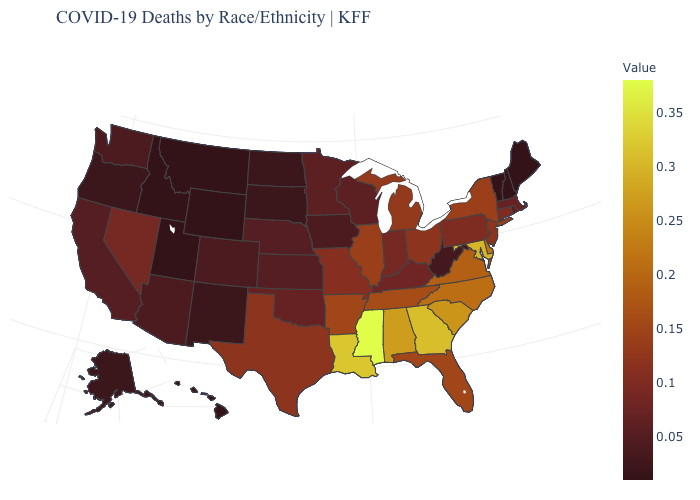Among the states that border Mississippi , which have the highest value?
Keep it brief. Louisiana. Which states have the lowest value in the USA?
Concise answer only. Hawaii, Idaho, Maine, Montana, New Hampshire, Utah, Vermont, Wyoming. Does Maryland have the highest value in the South?
Give a very brief answer. No. Does Ohio have a lower value than South Dakota?
Quick response, please. No. Which states have the highest value in the USA?
Give a very brief answer. Mississippi. Does New York have the lowest value in the Northeast?
Concise answer only. No. 